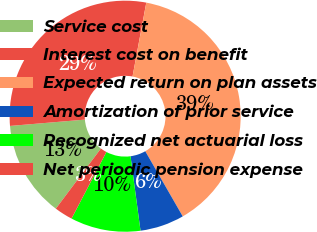Convert chart to OTSL. <chart><loc_0><loc_0><loc_500><loc_500><pie_chart><fcel>Service cost<fcel>Interest cost on benefit<fcel>Expected return on plan assets<fcel>Amortization of prior service<fcel>Recognized net actuarial loss<fcel>Net periodic pension expense<nl><fcel>13.42%<fcel>29.27%<fcel>38.76%<fcel>6.18%<fcel>9.8%<fcel>2.56%<nl></chart> 